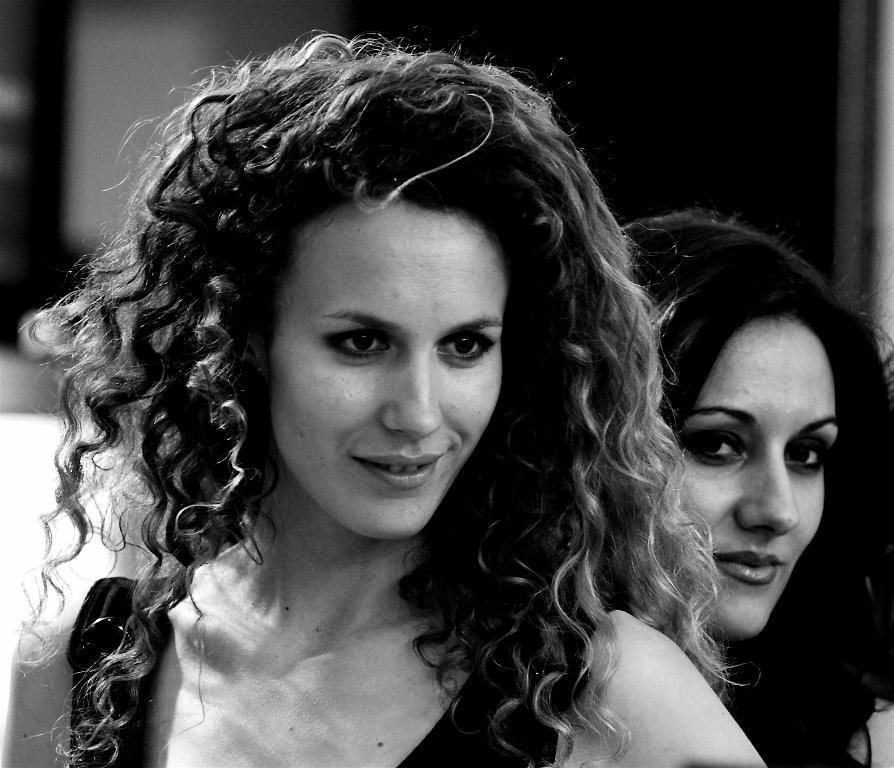In one or two sentences, can you explain what this image depicts? This is a black and white image. Here I can see two women are looking at the right side and smiling. The background is blurred. 